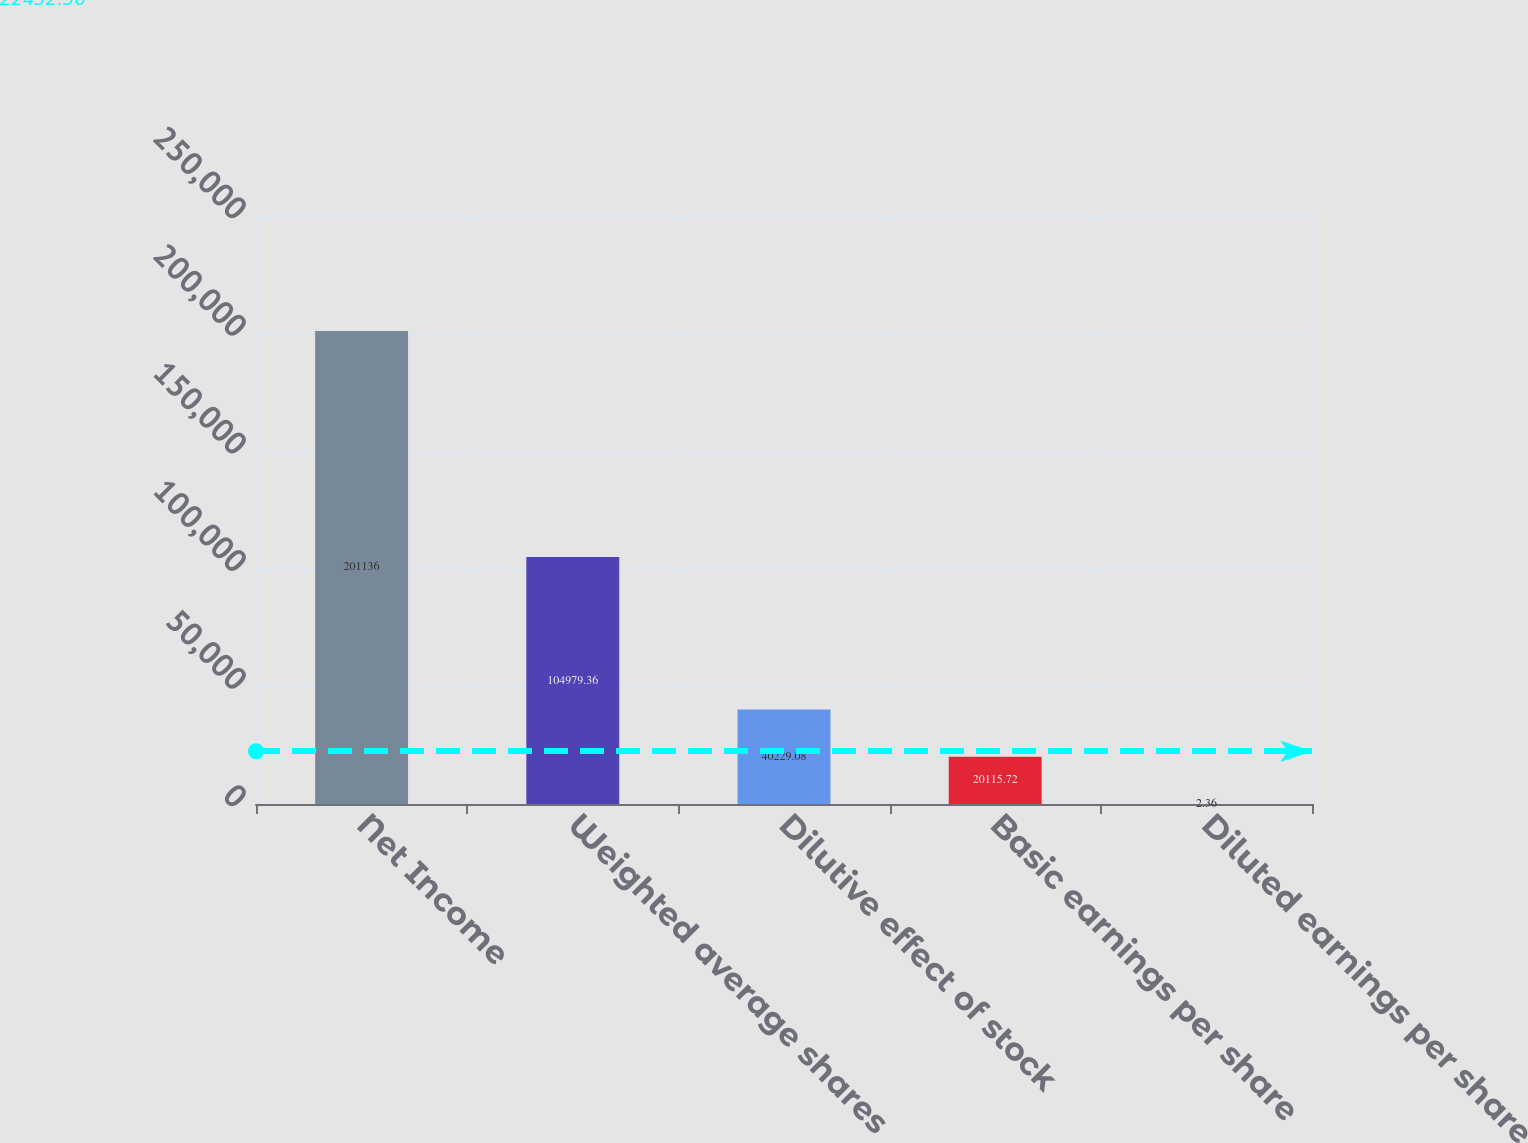Convert chart to OTSL. <chart><loc_0><loc_0><loc_500><loc_500><bar_chart><fcel>Net Income<fcel>Weighted average shares<fcel>Dilutive effect of stock<fcel>Basic earnings per share<fcel>Diluted earnings per share<nl><fcel>201136<fcel>104979<fcel>40229.1<fcel>20115.7<fcel>2.36<nl></chart> 